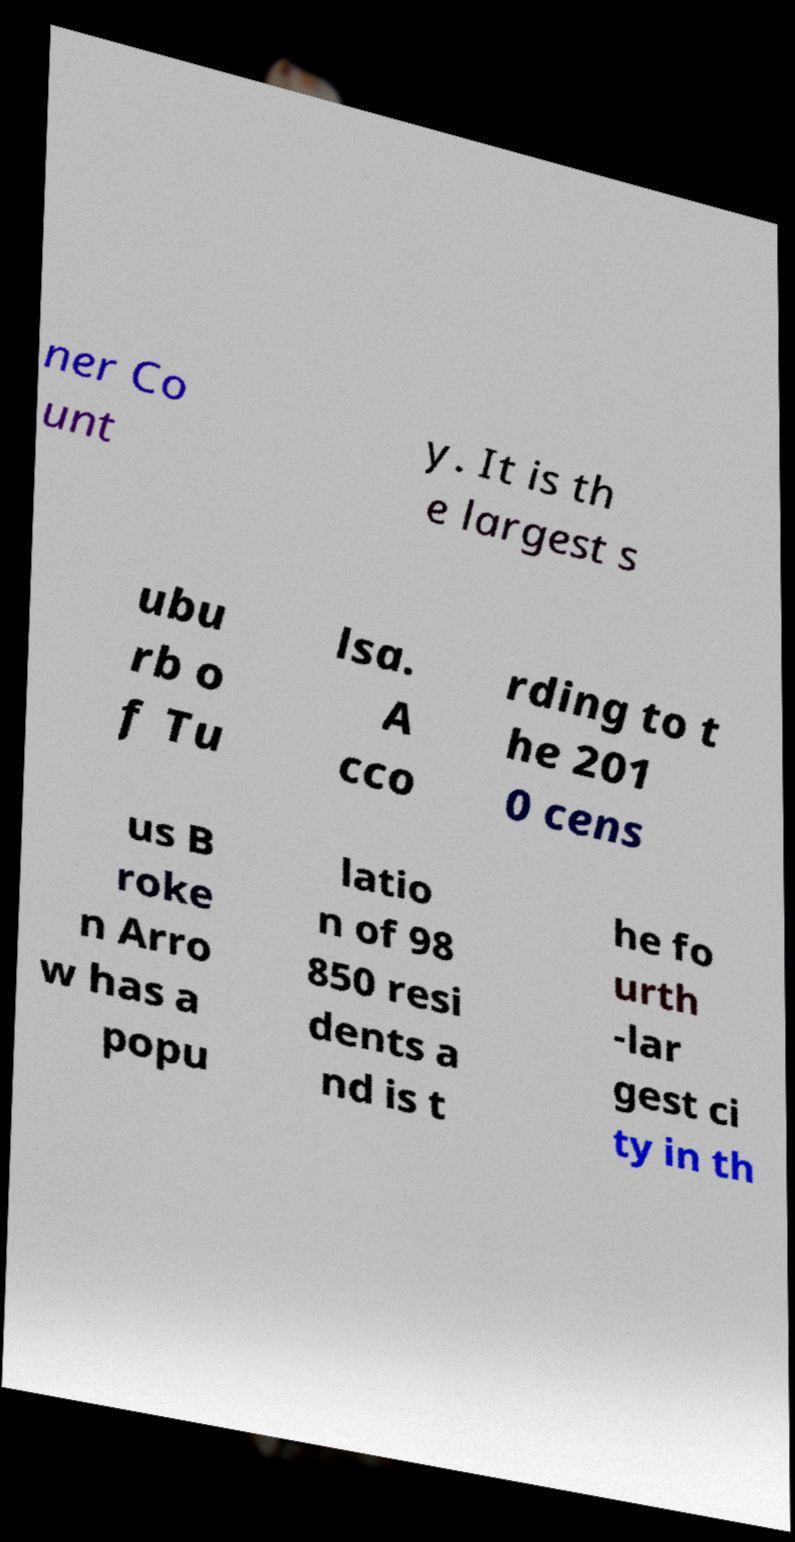Can you accurately transcribe the text from the provided image for me? ner Co unt y. It is th e largest s ubu rb o f Tu lsa. A cco rding to t he 201 0 cens us B roke n Arro w has a popu latio n of 98 850 resi dents a nd is t he fo urth -lar gest ci ty in th 